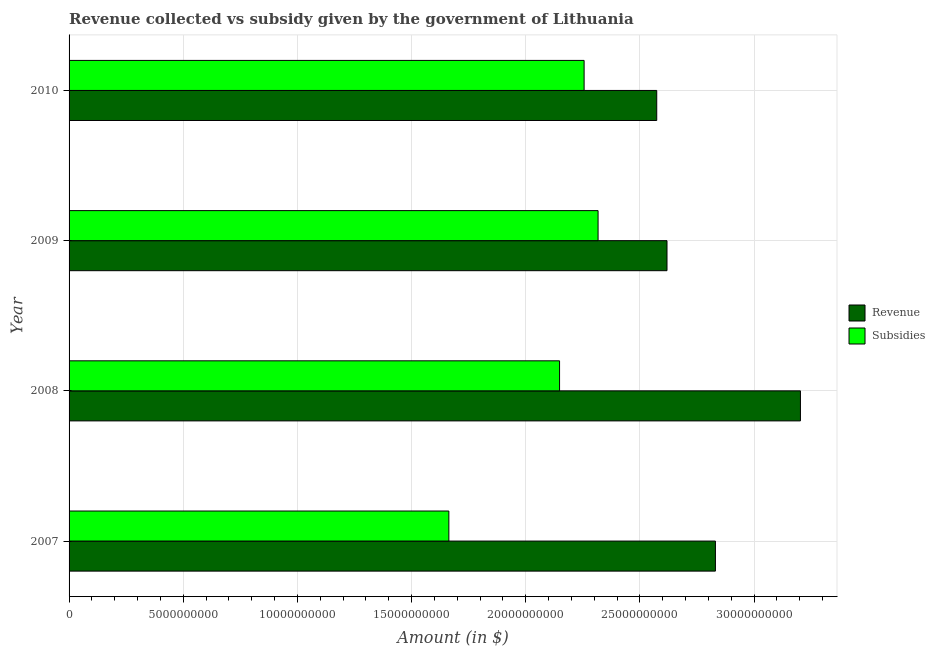Are the number of bars per tick equal to the number of legend labels?
Provide a succinct answer. Yes. Are the number of bars on each tick of the Y-axis equal?
Provide a short and direct response. Yes. How many bars are there on the 2nd tick from the bottom?
Ensure brevity in your answer.  2. What is the amount of revenue collected in 2010?
Keep it short and to the point. 2.57e+1. Across all years, what is the maximum amount of revenue collected?
Provide a short and direct response. 3.20e+1. Across all years, what is the minimum amount of revenue collected?
Give a very brief answer. 2.57e+1. In which year was the amount of revenue collected minimum?
Make the answer very short. 2010. What is the total amount of revenue collected in the graph?
Give a very brief answer. 1.12e+11. What is the difference between the amount of revenue collected in 2008 and that in 2009?
Provide a short and direct response. 5.84e+09. What is the difference between the amount of revenue collected in 2010 and the amount of subsidies given in 2007?
Your answer should be very brief. 9.10e+09. What is the average amount of revenue collected per year?
Your answer should be compact. 2.81e+1. In the year 2008, what is the difference between the amount of subsidies given and amount of revenue collected?
Your answer should be compact. -1.05e+1. In how many years, is the amount of subsidies given greater than 18000000000 $?
Your answer should be very brief. 3. What is the ratio of the amount of revenue collected in 2008 to that in 2010?
Ensure brevity in your answer.  1.25. Is the difference between the amount of subsidies given in 2008 and 2009 greater than the difference between the amount of revenue collected in 2008 and 2009?
Your response must be concise. No. What is the difference between the highest and the second highest amount of revenue collected?
Ensure brevity in your answer.  3.72e+09. What is the difference between the highest and the lowest amount of subsidies given?
Offer a terse response. 6.53e+09. In how many years, is the amount of revenue collected greater than the average amount of revenue collected taken over all years?
Offer a very short reply. 2. Is the sum of the amount of revenue collected in 2008 and 2009 greater than the maximum amount of subsidies given across all years?
Your answer should be compact. Yes. What does the 1st bar from the top in 2009 represents?
Make the answer very short. Subsidies. What does the 2nd bar from the bottom in 2007 represents?
Your answer should be very brief. Subsidies. How many years are there in the graph?
Offer a very short reply. 4. What is the difference between two consecutive major ticks on the X-axis?
Make the answer very short. 5.00e+09. Are the values on the major ticks of X-axis written in scientific E-notation?
Give a very brief answer. No. Where does the legend appear in the graph?
Give a very brief answer. Center right. How are the legend labels stacked?
Ensure brevity in your answer.  Vertical. What is the title of the graph?
Your answer should be compact. Revenue collected vs subsidy given by the government of Lithuania. Does "Agricultural land" appear as one of the legend labels in the graph?
Give a very brief answer. No. What is the label or title of the X-axis?
Your answer should be very brief. Amount (in $). What is the label or title of the Y-axis?
Your answer should be very brief. Year. What is the Amount (in $) of Revenue in 2007?
Your response must be concise. 2.83e+1. What is the Amount (in $) in Subsidies in 2007?
Ensure brevity in your answer.  1.66e+1. What is the Amount (in $) in Revenue in 2008?
Your response must be concise. 3.20e+1. What is the Amount (in $) in Subsidies in 2008?
Keep it short and to the point. 2.15e+1. What is the Amount (in $) of Revenue in 2009?
Offer a very short reply. 2.62e+1. What is the Amount (in $) in Subsidies in 2009?
Ensure brevity in your answer.  2.32e+1. What is the Amount (in $) in Revenue in 2010?
Your answer should be compact. 2.57e+1. What is the Amount (in $) of Subsidies in 2010?
Offer a very short reply. 2.26e+1. Across all years, what is the maximum Amount (in $) of Revenue?
Offer a very short reply. 3.20e+1. Across all years, what is the maximum Amount (in $) in Subsidies?
Provide a short and direct response. 2.32e+1. Across all years, what is the minimum Amount (in $) of Revenue?
Provide a succinct answer. 2.57e+1. Across all years, what is the minimum Amount (in $) of Subsidies?
Provide a short and direct response. 1.66e+1. What is the total Amount (in $) of Revenue in the graph?
Offer a terse response. 1.12e+11. What is the total Amount (in $) in Subsidies in the graph?
Provide a short and direct response. 8.38e+1. What is the difference between the Amount (in $) in Revenue in 2007 and that in 2008?
Offer a very short reply. -3.72e+09. What is the difference between the Amount (in $) of Subsidies in 2007 and that in 2008?
Offer a very short reply. -4.85e+09. What is the difference between the Amount (in $) of Revenue in 2007 and that in 2009?
Your answer should be very brief. 2.12e+09. What is the difference between the Amount (in $) of Subsidies in 2007 and that in 2009?
Your answer should be compact. -6.53e+09. What is the difference between the Amount (in $) in Revenue in 2007 and that in 2010?
Ensure brevity in your answer.  2.57e+09. What is the difference between the Amount (in $) of Subsidies in 2007 and that in 2010?
Your answer should be very brief. -5.92e+09. What is the difference between the Amount (in $) in Revenue in 2008 and that in 2009?
Make the answer very short. 5.84e+09. What is the difference between the Amount (in $) of Subsidies in 2008 and that in 2009?
Your answer should be compact. -1.69e+09. What is the difference between the Amount (in $) of Revenue in 2008 and that in 2010?
Offer a terse response. 6.29e+09. What is the difference between the Amount (in $) in Subsidies in 2008 and that in 2010?
Your answer should be very brief. -1.08e+09. What is the difference between the Amount (in $) of Revenue in 2009 and that in 2010?
Give a very brief answer. 4.50e+08. What is the difference between the Amount (in $) in Subsidies in 2009 and that in 2010?
Offer a terse response. 6.11e+08. What is the difference between the Amount (in $) in Revenue in 2007 and the Amount (in $) in Subsidies in 2008?
Make the answer very short. 6.83e+09. What is the difference between the Amount (in $) in Revenue in 2007 and the Amount (in $) in Subsidies in 2009?
Your answer should be very brief. 5.14e+09. What is the difference between the Amount (in $) of Revenue in 2007 and the Amount (in $) of Subsidies in 2010?
Offer a terse response. 5.75e+09. What is the difference between the Amount (in $) in Revenue in 2008 and the Amount (in $) in Subsidies in 2009?
Provide a succinct answer. 8.86e+09. What is the difference between the Amount (in $) in Revenue in 2008 and the Amount (in $) in Subsidies in 2010?
Offer a very short reply. 9.47e+09. What is the difference between the Amount (in $) of Revenue in 2009 and the Amount (in $) of Subsidies in 2010?
Make the answer very short. 3.63e+09. What is the average Amount (in $) of Revenue per year?
Give a very brief answer. 2.81e+1. What is the average Amount (in $) in Subsidies per year?
Keep it short and to the point. 2.10e+1. In the year 2007, what is the difference between the Amount (in $) of Revenue and Amount (in $) of Subsidies?
Your answer should be compact. 1.17e+1. In the year 2008, what is the difference between the Amount (in $) of Revenue and Amount (in $) of Subsidies?
Your answer should be very brief. 1.05e+1. In the year 2009, what is the difference between the Amount (in $) of Revenue and Amount (in $) of Subsidies?
Provide a short and direct response. 3.02e+09. In the year 2010, what is the difference between the Amount (in $) in Revenue and Amount (in $) in Subsidies?
Your answer should be compact. 3.18e+09. What is the ratio of the Amount (in $) in Revenue in 2007 to that in 2008?
Your response must be concise. 0.88. What is the ratio of the Amount (in $) of Subsidies in 2007 to that in 2008?
Your response must be concise. 0.77. What is the ratio of the Amount (in $) in Revenue in 2007 to that in 2009?
Offer a terse response. 1.08. What is the ratio of the Amount (in $) of Subsidies in 2007 to that in 2009?
Make the answer very short. 0.72. What is the ratio of the Amount (in $) of Revenue in 2007 to that in 2010?
Ensure brevity in your answer.  1.1. What is the ratio of the Amount (in $) of Subsidies in 2007 to that in 2010?
Ensure brevity in your answer.  0.74. What is the ratio of the Amount (in $) of Revenue in 2008 to that in 2009?
Your response must be concise. 1.22. What is the ratio of the Amount (in $) in Subsidies in 2008 to that in 2009?
Provide a succinct answer. 0.93. What is the ratio of the Amount (in $) of Revenue in 2008 to that in 2010?
Make the answer very short. 1.24. What is the ratio of the Amount (in $) in Subsidies in 2008 to that in 2010?
Offer a terse response. 0.95. What is the ratio of the Amount (in $) in Revenue in 2009 to that in 2010?
Your response must be concise. 1.02. What is the ratio of the Amount (in $) of Subsidies in 2009 to that in 2010?
Your answer should be very brief. 1.03. What is the difference between the highest and the second highest Amount (in $) of Revenue?
Your answer should be very brief. 3.72e+09. What is the difference between the highest and the second highest Amount (in $) of Subsidies?
Provide a short and direct response. 6.11e+08. What is the difference between the highest and the lowest Amount (in $) of Revenue?
Give a very brief answer. 6.29e+09. What is the difference between the highest and the lowest Amount (in $) in Subsidies?
Ensure brevity in your answer.  6.53e+09. 